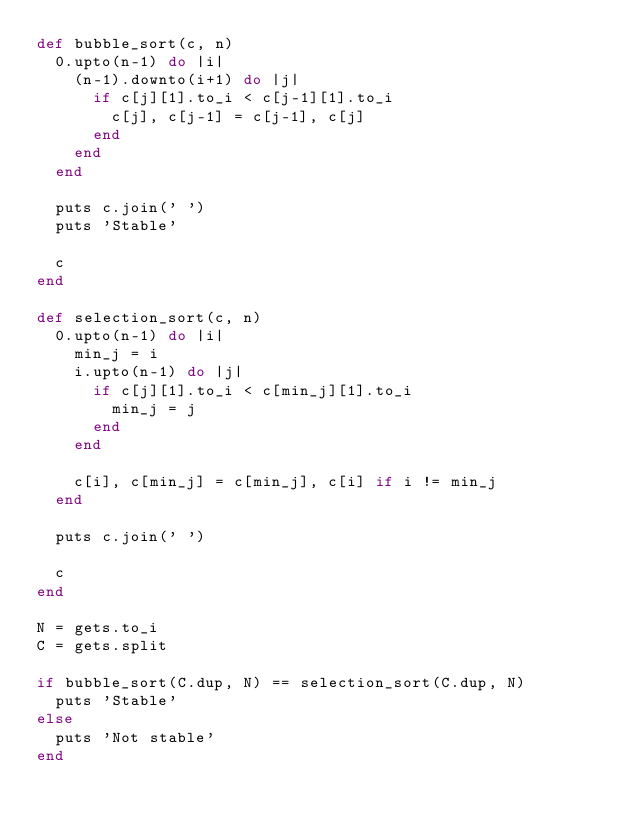Convert code to text. <code><loc_0><loc_0><loc_500><loc_500><_Ruby_>def bubble_sort(c, n)
  0.upto(n-1) do |i|
    (n-1).downto(i+1) do |j|
      if c[j][1].to_i < c[j-1][1].to_i
        c[j], c[j-1] = c[j-1], c[j]
      end
    end
  end

  puts c.join(' ')
  puts 'Stable'

  c
end

def selection_sort(c, n)
  0.upto(n-1) do |i|
    min_j = i
    i.upto(n-1) do |j|
      if c[j][1].to_i < c[min_j][1].to_i
        min_j = j
      end
    end

    c[i], c[min_j] = c[min_j], c[i] if i != min_j
  end

  puts c.join(' ')

  c
end

N = gets.to_i
C = gets.split

if bubble_sort(C.dup, N) == selection_sort(C.dup, N)
  puts 'Stable'
else
  puts 'Not stable'
end</code> 